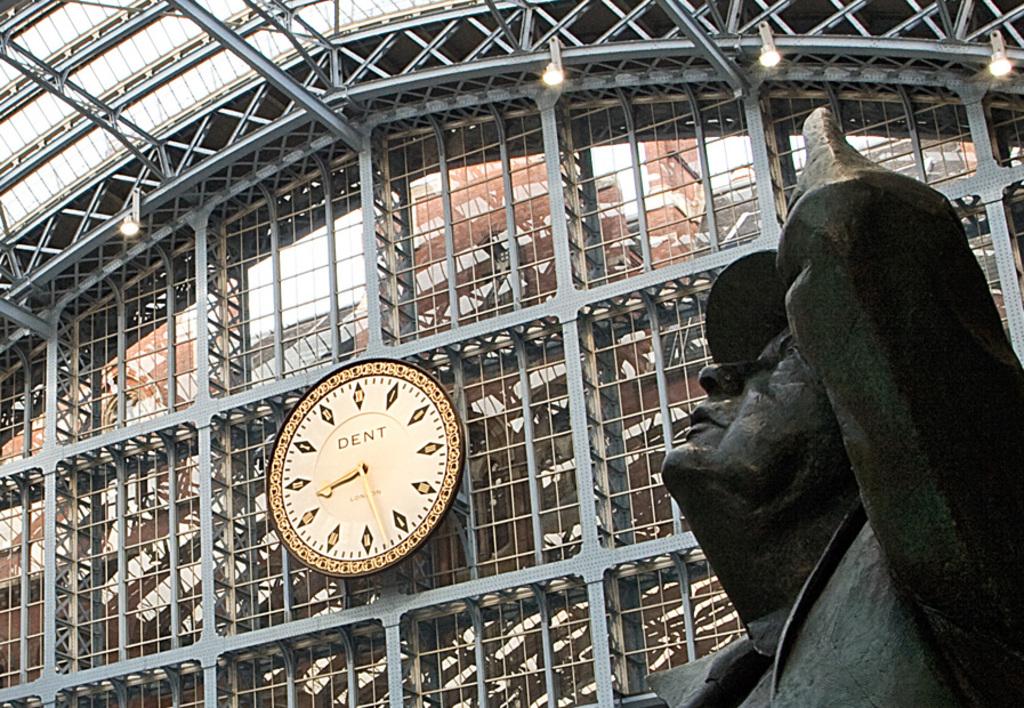Who built the clock?
Offer a terse response. Dent. 